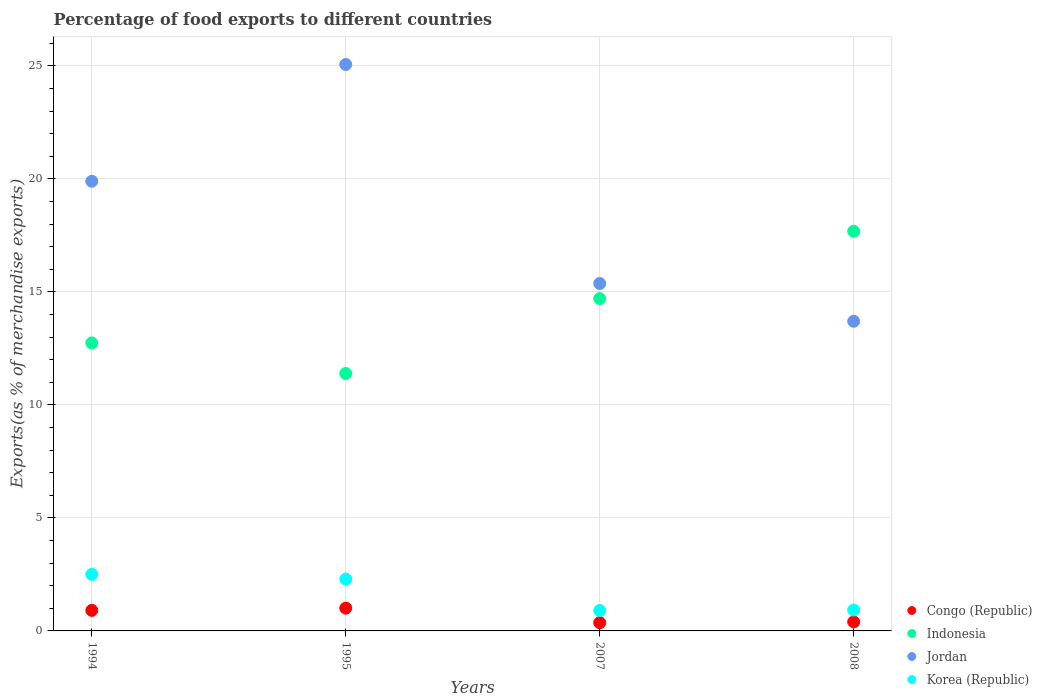What is the percentage of exports to different countries in Jordan in 2007?
Provide a succinct answer. 15.37. Across all years, what is the maximum percentage of exports to different countries in Congo (Republic)?
Make the answer very short. 1.01. Across all years, what is the minimum percentage of exports to different countries in Korea (Republic)?
Offer a terse response. 0.9. In which year was the percentage of exports to different countries in Indonesia maximum?
Keep it short and to the point. 2008. What is the total percentage of exports to different countries in Jordan in the graph?
Provide a short and direct response. 74.04. What is the difference between the percentage of exports to different countries in Congo (Republic) in 1994 and that in 2008?
Make the answer very short. 0.51. What is the difference between the percentage of exports to different countries in Indonesia in 2008 and the percentage of exports to different countries in Korea (Republic) in 2007?
Give a very brief answer. 16.78. What is the average percentage of exports to different countries in Korea (Republic) per year?
Keep it short and to the point. 1.66. In the year 1994, what is the difference between the percentage of exports to different countries in Congo (Republic) and percentage of exports to different countries in Jordan?
Ensure brevity in your answer.  -18.99. In how many years, is the percentage of exports to different countries in Korea (Republic) greater than 25 %?
Offer a very short reply. 0. What is the ratio of the percentage of exports to different countries in Jordan in 1994 to that in 2007?
Offer a terse response. 1.29. Is the percentage of exports to different countries in Korea (Republic) in 1995 less than that in 2007?
Provide a short and direct response. No. What is the difference between the highest and the second highest percentage of exports to different countries in Indonesia?
Your answer should be very brief. 2.98. What is the difference between the highest and the lowest percentage of exports to different countries in Jordan?
Offer a terse response. 11.36. Does the percentage of exports to different countries in Indonesia monotonically increase over the years?
Your response must be concise. No. Is the percentage of exports to different countries in Indonesia strictly greater than the percentage of exports to different countries in Jordan over the years?
Your answer should be very brief. No. How many years are there in the graph?
Ensure brevity in your answer.  4. What is the difference between two consecutive major ticks on the Y-axis?
Your response must be concise. 5. What is the title of the graph?
Offer a terse response. Percentage of food exports to different countries. Does "Argentina" appear as one of the legend labels in the graph?
Ensure brevity in your answer.  No. What is the label or title of the Y-axis?
Give a very brief answer. Exports(as % of merchandise exports). What is the Exports(as % of merchandise exports) of Congo (Republic) in 1994?
Provide a short and direct response. 0.91. What is the Exports(as % of merchandise exports) in Indonesia in 1994?
Offer a very short reply. 12.74. What is the Exports(as % of merchandise exports) in Jordan in 1994?
Offer a very short reply. 19.9. What is the Exports(as % of merchandise exports) of Korea (Republic) in 1994?
Make the answer very short. 2.5. What is the Exports(as % of merchandise exports) in Congo (Republic) in 1995?
Your answer should be compact. 1.01. What is the Exports(as % of merchandise exports) of Indonesia in 1995?
Your answer should be compact. 11.39. What is the Exports(as % of merchandise exports) of Jordan in 1995?
Keep it short and to the point. 25.07. What is the Exports(as % of merchandise exports) in Korea (Republic) in 1995?
Provide a short and direct response. 2.29. What is the Exports(as % of merchandise exports) of Congo (Republic) in 2007?
Offer a very short reply. 0.36. What is the Exports(as % of merchandise exports) in Indonesia in 2007?
Your answer should be compact. 14.71. What is the Exports(as % of merchandise exports) in Jordan in 2007?
Your response must be concise. 15.37. What is the Exports(as % of merchandise exports) in Korea (Republic) in 2007?
Ensure brevity in your answer.  0.9. What is the Exports(as % of merchandise exports) in Congo (Republic) in 2008?
Provide a succinct answer. 0.4. What is the Exports(as % of merchandise exports) of Indonesia in 2008?
Give a very brief answer. 17.69. What is the Exports(as % of merchandise exports) of Jordan in 2008?
Provide a short and direct response. 13.7. What is the Exports(as % of merchandise exports) in Korea (Republic) in 2008?
Your answer should be compact. 0.92. Across all years, what is the maximum Exports(as % of merchandise exports) in Congo (Republic)?
Provide a succinct answer. 1.01. Across all years, what is the maximum Exports(as % of merchandise exports) of Indonesia?
Keep it short and to the point. 17.69. Across all years, what is the maximum Exports(as % of merchandise exports) of Jordan?
Provide a succinct answer. 25.07. Across all years, what is the maximum Exports(as % of merchandise exports) of Korea (Republic)?
Provide a short and direct response. 2.5. Across all years, what is the minimum Exports(as % of merchandise exports) of Congo (Republic)?
Ensure brevity in your answer.  0.36. Across all years, what is the minimum Exports(as % of merchandise exports) of Indonesia?
Provide a short and direct response. 11.39. Across all years, what is the minimum Exports(as % of merchandise exports) in Jordan?
Provide a short and direct response. 13.7. Across all years, what is the minimum Exports(as % of merchandise exports) in Korea (Republic)?
Make the answer very short. 0.9. What is the total Exports(as % of merchandise exports) of Congo (Republic) in the graph?
Provide a short and direct response. 2.68. What is the total Exports(as % of merchandise exports) of Indonesia in the graph?
Provide a succinct answer. 56.53. What is the total Exports(as % of merchandise exports) of Jordan in the graph?
Your response must be concise. 74.04. What is the total Exports(as % of merchandise exports) of Korea (Republic) in the graph?
Ensure brevity in your answer.  6.63. What is the difference between the Exports(as % of merchandise exports) in Congo (Republic) in 1994 and that in 1995?
Give a very brief answer. -0.1. What is the difference between the Exports(as % of merchandise exports) of Indonesia in 1994 and that in 1995?
Keep it short and to the point. 1.35. What is the difference between the Exports(as % of merchandise exports) in Jordan in 1994 and that in 1995?
Give a very brief answer. -5.17. What is the difference between the Exports(as % of merchandise exports) of Korea (Republic) in 1994 and that in 1995?
Provide a succinct answer. 0.21. What is the difference between the Exports(as % of merchandise exports) in Congo (Republic) in 1994 and that in 2007?
Provide a succinct answer. 0.54. What is the difference between the Exports(as % of merchandise exports) in Indonesia in 1994 and that in 2007?
Provide a short and direct response. -1.96. What is the difference between the Exports(as % of merchandise exports) in Jordan in 1994 and that in 2007?
Make the answer very short. 4.52. What is the difference between the Exports(as % of merchandise exports) in Korea (Republic) in 1994 and that in 2007?
Ensure brevity in your answer.  1.6. What is the difference between the Exports(as % of merchandise exports) in Congo (Republic) in 1994 and that in 2008?
Your answer should be compact. 0.51. What is the difference between the Exports(as % of merchandise exports) in Indonesia in 1994 and that in 2008?
Provide a succinct answer. -4.94. What is the difference between the Exports(as % of merchandise exports) of Jordan in 1994 and that in 2008?
Offer a terse response. 6.2. What is the difference between the Exports(as % of merchandise exports) of Korea (Republic) in 1994 and that in 2008?
Offer a very short reply. 1.58. What is the difference between the Exports(as % of merchandise exports) of Congo (Republic) in 1995 and that in 2007?
Give a very brief answer. 0.64. What is the difference between the Exports(as % of merchandise exports) of Indonesia in 1995 and that in 2007?
Offer a very short reply. -3.31. What is the difference between the Exports(as % of merchandise exports) in Jordan in 1995 and that in 2007?
Your answer should be very brief. 9.69. What is the difference between the Exports(as % of merchandise exports) of Korea (Republic) in 1995 and that in 2007?
Your answer should be compact. 1.39. What is the difference between the Exports(as % of merchandise exports) of Congo (Republic) in 1995 and that in 2008?
Give a very brief answer. 0.61. What is the difference between the Exports(as % of merchandise exports) of Indonesia in 1995 and that in 2008?
Make the answer very short. -6.29. What is the difference between the Exports(as % of merchandise exports) of Jordan in 1995 and that in 2008?
Ensure brevity in your answer.  11.36. What is the difference between the Exports(as % of merchandise exports) of Korea (Republic) in 1995 and that in 2008?
Ensure brevity in your answer.  1.37. What is the difference between the Exports(as % of merchandise exports) in Congo (Republic) in 2007 and that in 2008?
Your response must be concise. -0.03. What is the difference between the Exports(as % of merchandise exports) of Indonesia in 2007 and that in 2008?
Ensure brevity in your answer.  -2.98. What is the difference between the Exports(as % of merchandise exports) in Jordan in 2007 and that in 2008?
Offer a very short reply. 1.67. What is the difference between the Exports(as % of merchandise exports) of Korea (Republic) in 2007 and that in 2008?
Ensure brevity in your answer.  -0.02. What is the difference between the Exports(as % of merchandise exports) in Congo (Republic) in 1994 and the Exports(as % of merchandise exports) in Indonesia in 1995?
Keep it short and to the point. -10.48. What is the difference between the Exports(as % of merchandise exports) in Congo (Republic) in 1994 and the Exports(as % of merchandise exports) in Jordan in 1995?
Provide a short and direct response. -24.16. What is the difference between the Exports(as % of merchandise exports) of Congo (Republic) in 1994 and the Exports(as % of merchandise exports) of Korea (Republic) in 1995?
Give a very brief answer. -1.39. What is the difference between the Exports(as % of merchandise exports) of Indonesia in 1994 and the Exports(as % of merchandise exports) of Jordan in 1995?
Ensure brevity in your answer.  -12.32. What is the difference between the Exports(as % of merchandise exports) in Indonesia in 1994 and the Exports(as % of merchandise exports) in Korea (Republic) in 1995?
Provide a succinct answer. 10.45. What is the difference between the Exports(as % of merchandise exports) in Jordan in 1994 and the Exports(as % of merchandise exports) in Korea (Republic) in 1995?
Provide a short and direct response. 17.6. What is the difference between the Exports(as % of merchandise exports) in Congo (Republic) in 1994 and the Exports(as % of merchandise exports) in Indonesia in 2007?
Provide a succinct answer. -13.8. What is the difference between the Exports(as % of merchandise exports) of Congo (Republic) in 1994 and the Exports(as % of merchandise exports) of Jordan in 2007?
Your answer should be compact. -14.47. What is the difference between the Exports(as % of merchandise exports) of Congo (Republic) in 1994 and the Exports(as % of merchandise exports) of Korea (Republic) in 2007?
Keep it short and to the point. 0.01. What is the difference between the Exports(as % of merchandise exports) in Indonesia in 1994 and the Exports(as % of merchandise exports) in Jordan in 2007?
Give a very brief answer. -2.63. What is the difference between the Exports(as % of merchandise exports) in Indonesia in 1994 and the Exports(as % of merchandise exports) in Korea (Republic) in 2007?
Keep it short and to the point. 11.84. What is the difference between the Exports(as % of merchandise exports) in Jordan in 1994 and the Exports(as % of merchandise exports) in Korea (Republic) in 2007?
Provide a succinct answer. 19. What is the difference between the Exports(as % of merchandise exports) in Congo (Republic) in 1994 and the Exports(as % of merchandise exports) in Indonesia in 2008?
Your answer should be very brief. -16.78. What is the difference between the Exports(as % of merchandise exports) in Congo (Republic) in 1994 and the Exports(as % of merchandise exports) in Jordan in 2008?
Keep it short and to the point. -12.79. What is the difference between the Exports(as % of merchandise exports) in Congo (Republic) in 1994 and the Exports(as % of merchandise exports) in Korea (Republic) in 2008?
Offer a very short reply. -0.02. What is the difference between the Exports(as % of merchandise exports) in Indonesia in 1994 and the Exports(as % of merchandise exports) in Jordan in 2008?
Give a very brief answer. -0.96. What is the difference between the Exports(as % of merchandise exports) in Indonesia in 1994 and the Exports(as % of merchandise exports) in Korea (Republic) in 2008?
Your answer should be very brief. 11.82. What is the difference between the Exports(as % of merchandise exports) in Jordan in 1994 and the Exports(as % of merchandise exports) in Korea (Republic) in 2008?
Make the answer very short. 18.97. What is the difference between the Exports(as % of merchandise exports) in Congo (Republic) in 1995 and the Exports(as % of merchandise exports) in Indonesia in 2007?
Your answer should be compact. -13.7. What is the difference between the Exports(as % of merchandise exports) of Congo (Republic) in 1995 and the Exports(as % of merchandise exports) of Jordan in 2007?
Make the answer very short. -14.37. What is the difference between the Exports(as % of merchandise exports) of Congo (Republic) in 1995 and the Exports(as % of merchandise exports) of Korea (Republic) in 2007?
Ensure brevity in your answer.  0.1. What is the difference between the Exports(as % of merchandise exports) of Indonesia in 1995 and the Exports(as % of merchandise exports) of Jordan in 2007?
Ensure brevity in your answer.  -3.98. What is the difference between the Exports(as % of merchandise exports) in Indonesia in 1995 and the Exports(as % of merchandise exports) in Korea (Republic) in 2007?
Offer a very short reply. 10.49. What is the difference between the Exports(as % of merchandise exports) in Jordan in 1995 and the Exports(as % of merchandise exports) in Korea (Republic) in 2007?
Provide a succinct answer. 24.16. What is the difference between the Exports(as % of merchandise exports) in Congo (Republic) in 1995 and the Exports(as % of merchandise exports) in Indonesia in 2008?
Your answer should be very brief. -16.68. What is the difference between the Exports(as % of merchandise exports) in Congo (Republic) in 1995 and the Exports(as % of merchandise exports) in Jordan in 2008?
Provide a short and direct response. -12.7. What is the difference between the Exports(as % of merchandise exports) of Congo (Republic) in 1995 and the Exports(as % of merchandise exports) of Korea (Republic) in 2008?
Provide a short and direct response. 0.08. What is the difference between the Exports(as % of merchandise exports) of Indonesia in 1995 and the Exports(as % of merchandise exports) of Jordan in 2008?
Give a very brief answer. -2.31. What is the difference between the Exports(as % of merchandise exports) in Indonesia in 1995 and the Exports(as % of merchandise exports) in Korea (Republic) in 2008?
Offer a very short reply. 10.47. What is the difference between the Exports(as % of merchandise exports) of Jordan in 1995 and the Exports(as % of merchandise exports) of Korea (Republic) in 2008?
Your answer should be compact. 24.14. What is the difference between the Exports(as % of merchandise exports) of Congo (Republic) in 2007 and the Exports(as % of merchandise exports) of Indonesia in 2008?
Provide a succinct answer. -17.32. What is the difference between the Exports(as % of merchandise exports) in Congo (Republic) in 2007 and the Exports(as % of merchandise exports) in Jordan in 2008?
Your answer should be very brief. -13.34. What is the difference between the Exports(as % of merchandise exports) of Congo (Republic) in 2007 and the Exports(as % of merchandise exports) of Korea (Republic) in 2008?
Offer a very short reply. -0.56. What is the difference between the Exports(as % of merchandise exports) in Indonesia in 2007 and the Exports(as % of merchandise exports) in Korea (Republic) in 2008?
Provide a short and direct response. 13.78. What is the difference between the Exports(as % of merchandise exports) of Jordan in 2007 and the Exports(as % of merchandise exports) of Korea (Republic) in 2008?
Provide a short and direct response. 14.45. What is the average Exports(as % of merchandise exports) of Congo (Republic) per year?
Offer a terse response. 0.67. What is the average Exports(as % of merchandise exports) of Indonesia per year?
Provide a succinct answer. 14.13. What is the average Exports(as % of merchandise exports) of Jordan per year?
Ensure brevity in your answer.  18.51. What is the average Exports(as % of merchandise exports) in Korea (Republic) per year?
Ensure brevity in your answer.  1.66. In the year 1994, what is the difference between the Exports(as % of merchandise exports) of Congo (Republic) and Exports(as % of merchandise exports) of Indonesia?
Your response must be concise. -11.84. In the year 1994, what is the difference between the Exports(as % of merchandise exports) of Congo (Republic) and Exports(as % of merchandise exports) of Jordan?
Give a very brief answer. -18.99. In the year 1994, what is the difference between the Exports(as % of merchandise exports) in Congo (Republic) and Exports(as % of merchandise exports) in Korea (Republic)?
Keep it short and to the point. -1.59. In the year 1994, what is the difference between the Exports(as % of merchandise exports) in Indonesia and Exports(as % of merchandise exports) in Jordan?
Provide a succinct answer. -7.15. In the year 1994, what is the difference between the Exports(as % of merchandise exports) of Indonesia and Exports(as % of merchandise exports) of Korea (Republic)?
Your answer should be compact. 10.24. In the year 1994, what is the difference between the Exports(as % of merchandise exports) of Jordan and Exports(as % of merchandise exports) of Korea (Republic)?
Give a very brief answer. 17.39. In the year 1995, what is the difference between the Exports(as % of merchandise exports) of Congo (Republic) and Exports(as % of merchandise exports) of Indonesia?
Offer a very short reply. -10.39. In the year 1995, what is the difference between the Exports(as % of merchandise exports) of Congo (Republic) and Exports(as % of merchandise exports) of Jordan?
Offer a terse response. -24.06. In the year 1995, what is the difference between the Exports(as % of merchandise exports) of Congo (Republic) and Exports(as % of merchandise exports) of Korea (Republic)?
Provide a succinct answer. -1.29. In the year 1995, what is the difference between the Exports(as % of merchandise exports) of Indonesia and Exports(as % of merchandise exports) of Jordan?
Ensure brevity in your answer.  -13.67. In the year 1995, what is the difference between the Exports(as % of merchandise exports) in Indonesia and Exports(as % of merchandise exports) in Korea (Republic)?
Your response must be concise. 9.1. In the year 1995, what is the difference between the Exports(as % of merchandise exports) in Jordan and Exports(as % of merchandise exports) in Korea (Republic)?
Your answer should be very brief. 22.77. In the year 2007, what is the difference between the Exports(as % of merchandise exports) of Congo (Republic) and Exports(as % of merchandise exports) of Indonesia?
Your answer should be very brief. -14.34. In the year 2007, what is the difference between the Exports(as % of merchandise exports) of Congo (Republic) and Exports(as % of merchandise exports) of Jordan?
Your answer should be compact. -15.01. In the year 2007, what is the difference between the Exports(as % of merchandise exports) of Congo (Republic) and Exports(as % of merchandise exports) of Korea (Republic)?
Your response must be concise. -0.54. In the year 2007, what is the difference between the Exports(as % of merchandise exports) in Indonesia and Exports(as % of merchandise exports) in Jordan?
Provide a succinct answer. -0.67. In the year 2007, what is the difference between the Exports(as % of merchandise exports) of Indonesia and Exports(as % of merchandise exports) of Korea (Republic)?
Offer a very short reply. 13.8. In the year 2007, what is the difference between the Exports(as % of merchandise exports) of Jordan and Exports(as % of merchandise exports) of Korea (Republic)?
Your answer should be very brief. 14.47. In the year 2008, what is the difference between the Exports(as % of merchandise exports) of Congo (Republic) and Exports(as % of merchandise exports) of Indonesia?
Keep it short and to the point. -17.29. In the year 2008, what is the difference between the Exports(as % of merchandise exports) of Congo (Republic) and Exports(as % of merchandise exports) of Jordan?
Offer a terse response. -13.3. In the year 2008, what is the difference between the Exports(as % of merchandise exports) of Congo (Republic) and Exports(as % of merchandise exports) of Korea (Republic)?
Keep it short and to the point. -0.53. In the year 2008, what is the difference between the Exports(as % of merchandise exports) in Indonesia and Exports(as % of merchandise exports) in Jordan?
Offer a terse response. 3.98. In the year 2008, what is the difference between the Exports(as % of merchandise exports) of Indonesia and Exports(as % of merchandise exports) of Korea (Republic)?
Provide a succinct answer. 16.76. In the year 2008, what is the difference between the Exports(as % of merchandise exports) of Jordan and Exports(as % of merchandise exports) of Korea (Republic)?
Offer a terse response. 12.78. What is the ratio of the Exports(as % of merchandise exports) in Congo (Republic) in 1994 to that in 1995?
Give a very brief answer. 0.9. What is the ratio of the Exports(as % of merchandise exports) in Indonesia in 1994 to that in 1995?
Provide a short and direct response. 1.12. What is the ratio of the Exports(as % of merchandise exports) in Jordan in 1994 to that in 1995?
Your answer should be compact. 0.79. What is the ratio of the Exports(as % of merchandise exports) of Korea (Republic) in 1994 to that in 1995?
Provide a succinct answer. 1.09. What is the ratio of the Exports(as % of merchandise exports) of Congo (Republic) in 1994 to that in 2007?
Give a very brief answer. 2.49. What is the ratio of the Exports(as % of merchandise exports) in Indonesia in 1994 to that in 2007?
Offer a very short reply. 0.87. What is the ratio of the Exports(as % of merchandise exports) in Jordan in 1994 to that in 2007?
Provide a short and direct response. 1.29. What is the ratio of the Exports(as % of merchandise exports) of Korea (Republic) in 1994 to that in 2007?
Your response must be concise. 2.77. What is the ratio of the Exports(as % of merchandise exports) in Congo (Republic) in 1994 to that in 2008?
Your answer should be very brief. 2.28. What is the ratio of the Exports(as % of merchandise exports) of Indonesia in 1994 to that in 2008?
Give a very brief answer. 0.72. What is the ratio of the Exports(as % of merchandise exports) of Jordan in 1994 to that in 2008?
Offer a very short reply. 1.45. What is the ratio of the Exports(as % of merchandise exports) of Korea (Republic) in 1994 to that in 2008?
Provide a succinct answer. 2.71. What is the ratio of the Exports(as % of merchandise exports) in Congo (Republic) in 1995 to that in 2007?
Provide a short and direct response. 2.76. What is the ratio of the Exports(as % of merchandise exports) of Indonesia in 1995 to that in 2007?
Your answer should be compact. 0.77. What is the ratio of the Exports(as % of merchandise exports) of Jordan in 1995 to that in 2007?
Offer a very short reply. 1.63. What is the ratio of the Exports(as % of merchandise exports) of Korea (Republic) in 1995 to that in 2007?
Ensure brevity in your answer.  2.54. What is the ratio of the Exports(as % of merchandise exports) in Congo (Republic) in 1995 to that in 2008?
Provide a succinct answer. 2.53. What is the ratio of the Exports(as % of merchandise exports) of Indonesia in 1995 to that in 2008?
Offer a terse response. 0.64. What is the ratio of the Exports(as % of merchandise exports) of Jordan in 1995 to that in 2008?
Give a very brief answer. 1.83. What is the ratio of the Exports(as % of merchandise exports) of Korea (Republic) in 1995 to that in 2008?
Provide a succinct answer. 2.48. What is the ratio of the Exports(as % of merchandise exports) of Congo (Republic) in 2007 to that in 2008?
Ensure brevity in your answer.  0.91. What is the ratio of the Exports(as % of merchandise exports) of Indonesia in 2007 to that in 2008?
Offer a terse response. 0.83. What is the ratio of the Exports(as % of merchandise exports) in Jordan in 2007 to that in 2008?
Your answer should be compact. 1.12. What is the ratio of the Exports(as % of merchandise exports) of Korea (Republic) in 2007 to that in 2008?
Keep it short and to the point. 0.98. What is the difference between the highest and the second highest Exports(as % of merchandise exports) of Congo (Republic)?
Give a very brief answer. 0.1. What is the difference between the highest and the second highest Exports(as % of merchandise exports) of Indonesia?
Keep it short and to the point. 2.98. What is the difference between the highest and the second highest Exports(as % of merchandise exports) in Jordan?
Offer a terse response. 5.17. What is the difference between the highest and the second highest Exports(as % of merchandise exports) in Korea (Republic)?
Provide a short and direct response. 0.21. What is the difference between the highest and the lowest Exports(as % of merchandise exports) in Congo (Republic)?
Provide a succinct answer. 0.64. What is the difference between the highest and the lowest Exports(as % of merchandise exports) of Indonesia?
Your answer should be compact. 6.29. What is the difference between the highest and the lowest Exports(as % of merchandise exports) in Jordan?
Ensure brevity in your answer.  11.36. What is the difference between the highest and the lowest Exports(as % of merchandise exports) in Korea (Republic)?
Your response must be concise. 1.6. 